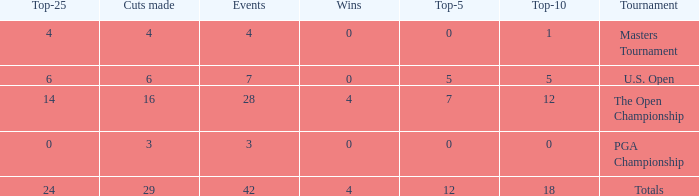What is the lowest for top-25 with events smaller than 42 in a U.S. Open with a top-10 smaller than 5? None. 